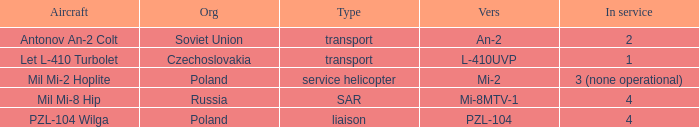Tell me the aircraft for pzl-104 PZL-104 Wilga. 